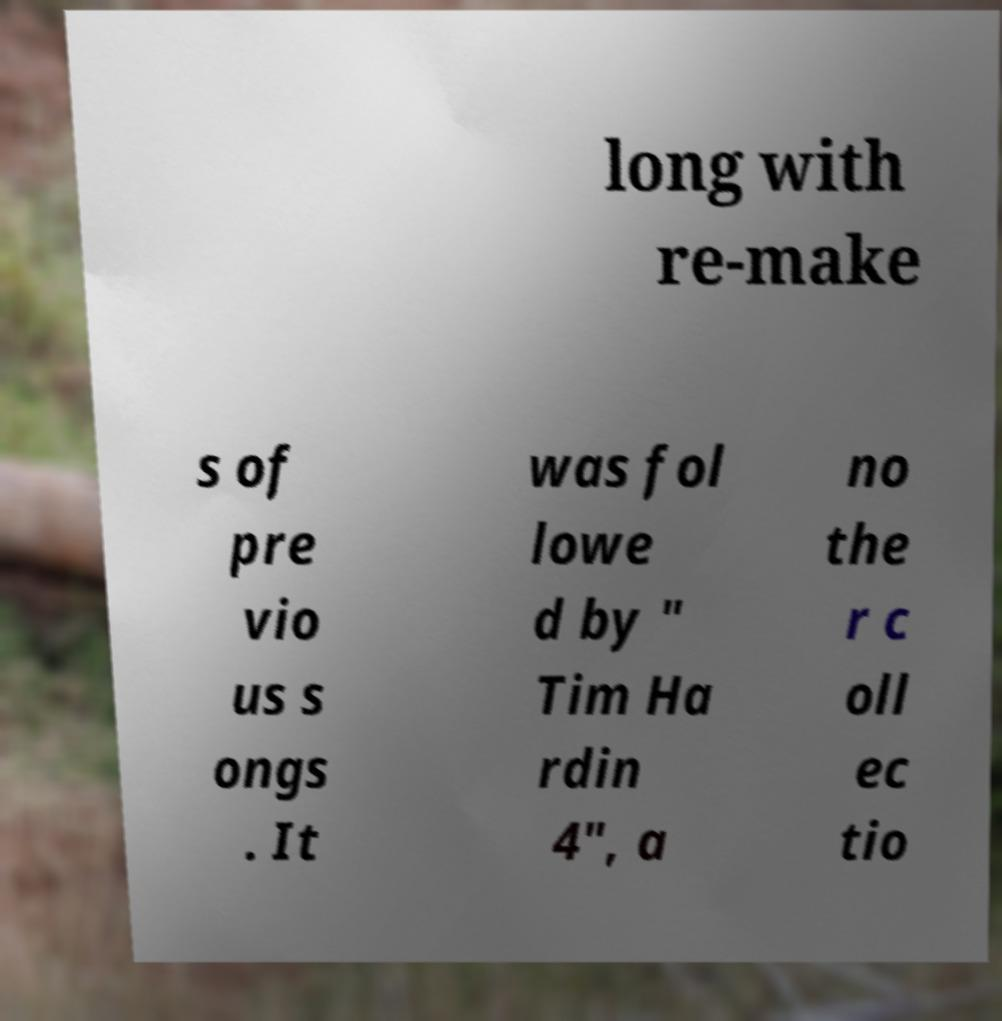There's text embedded in this image that I need extracted. Can you transcribe it verbatim? long with re-make s of pre vio us s ongs . It was fol lowe d by " Tim Ha rdin 4", a no the r c oll ec tio 